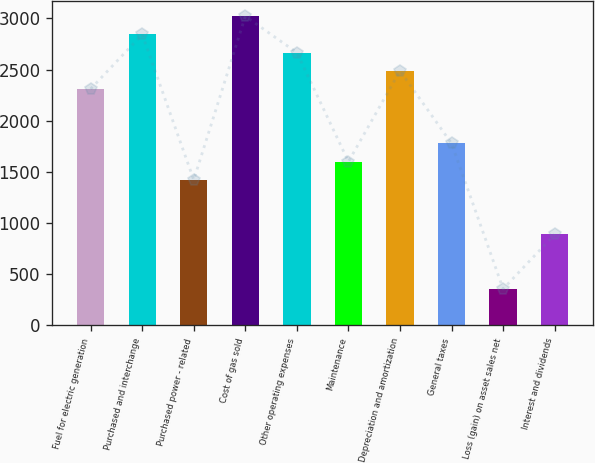<chart> <loc_0><loc_0><loc_500><loc_500><bar_chart><fcel>Fuel for electric generation<fcel>Purchased and interchange<fcel>Purchased power - related<fcel>Cost of gas sold<fcel>Other operating expenses<fcel>Maintenance<fcel>Depreciation and amortization<fcel>General taxes<fcel>Loss (gain) on asset sales net<fcel>Interest and dividends<nl><fcel>2310.8<fcel>2843.6<fcel>1422.8<fcel>3021.2<fcel>2666<fcel>1600.4<fcel>2488.4<fcel>1778<fcel>357.2<fcel>890<nl></chart> 